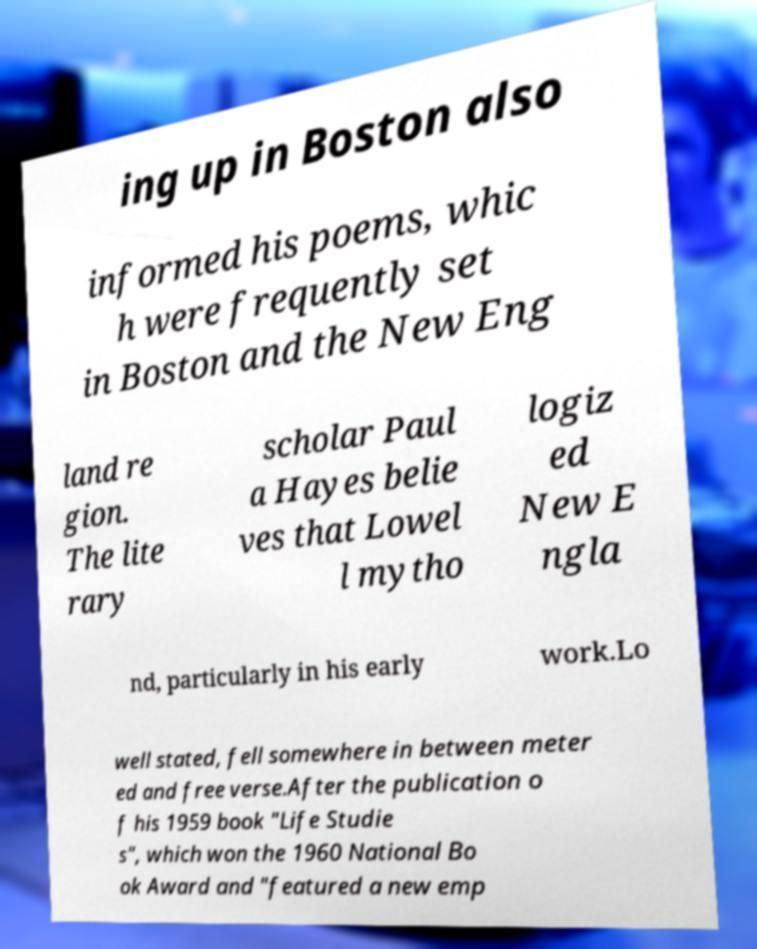For documentation purposes, I need the text within this image transcribed. Could you provide that? ing up in Boston also informed his poems, whic h were frequently set in Boston and the New Eng land re gion. The lite rary scholar Paul a Hayes belie ves that Lowel l mytho logiz ed New E ngla nd, particularly in his early work.Lo well stated, fell somewhere in between meter ed and free verse.After the publication o f his 1959 book "Life Studie s", which won the 1960 National Bo ok Award and "featured a new emp 